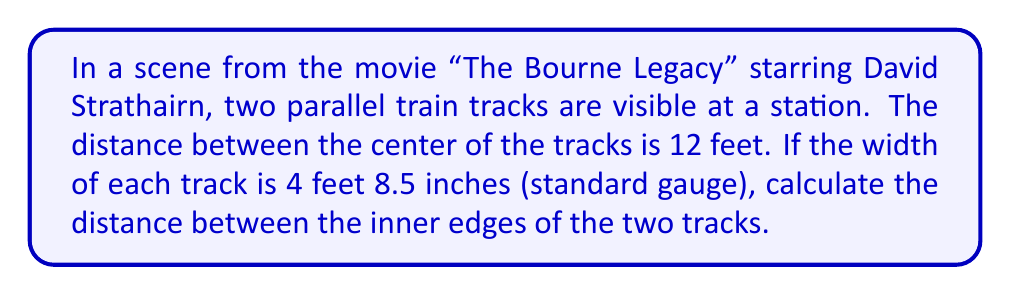Provide a solution to this math problem. Let's approach this step-by-step:

1) First, we need to convert all measurements to the same unit. Let's use feet:
   4 feet 8.5 inches = 4 + (8.5/12) = 4.7083 feet

2) Now, we have:
   - Distance between track centers: 12 feet
   - Width of each track: 4.7083 feet

3) Let's visualize the problem:
   [asy]
   size(200);
   draw((-60,0)--(60,0),blue);
   draw((-60,50)--(60,50),blue);
   draw((0,0)--(0,50),dashed);
   label("12 ft", (0,25), E);
   draw((-23.5,0)--(-23.5,50));
   draw((23.5,0)--(23.5,50));
   label("4.7083 ft", (-40,25), W);
   label("4.7083 ft", (40,25), E);
   label("?", (0,60), S);
   [/asy]

4) To find the distance between the inner edges, we need to subtract the width of both tracks from the center-to-center distance:

   $$ \text{Inner distance} = 12 - (4.7083 + 4.7083) $$

5) Simplifying:
   $$ \text{Inner distance} = 12 - 9.4166 = 2.5834 \text{ feet} $$

6) Converting back to feet and inches:
   0.5834 feet = 0.5834 * 12 = 7 inches

   So, 2.5834 feet = 2 feet 7 inches
Answer: 2 feet 7 inches 